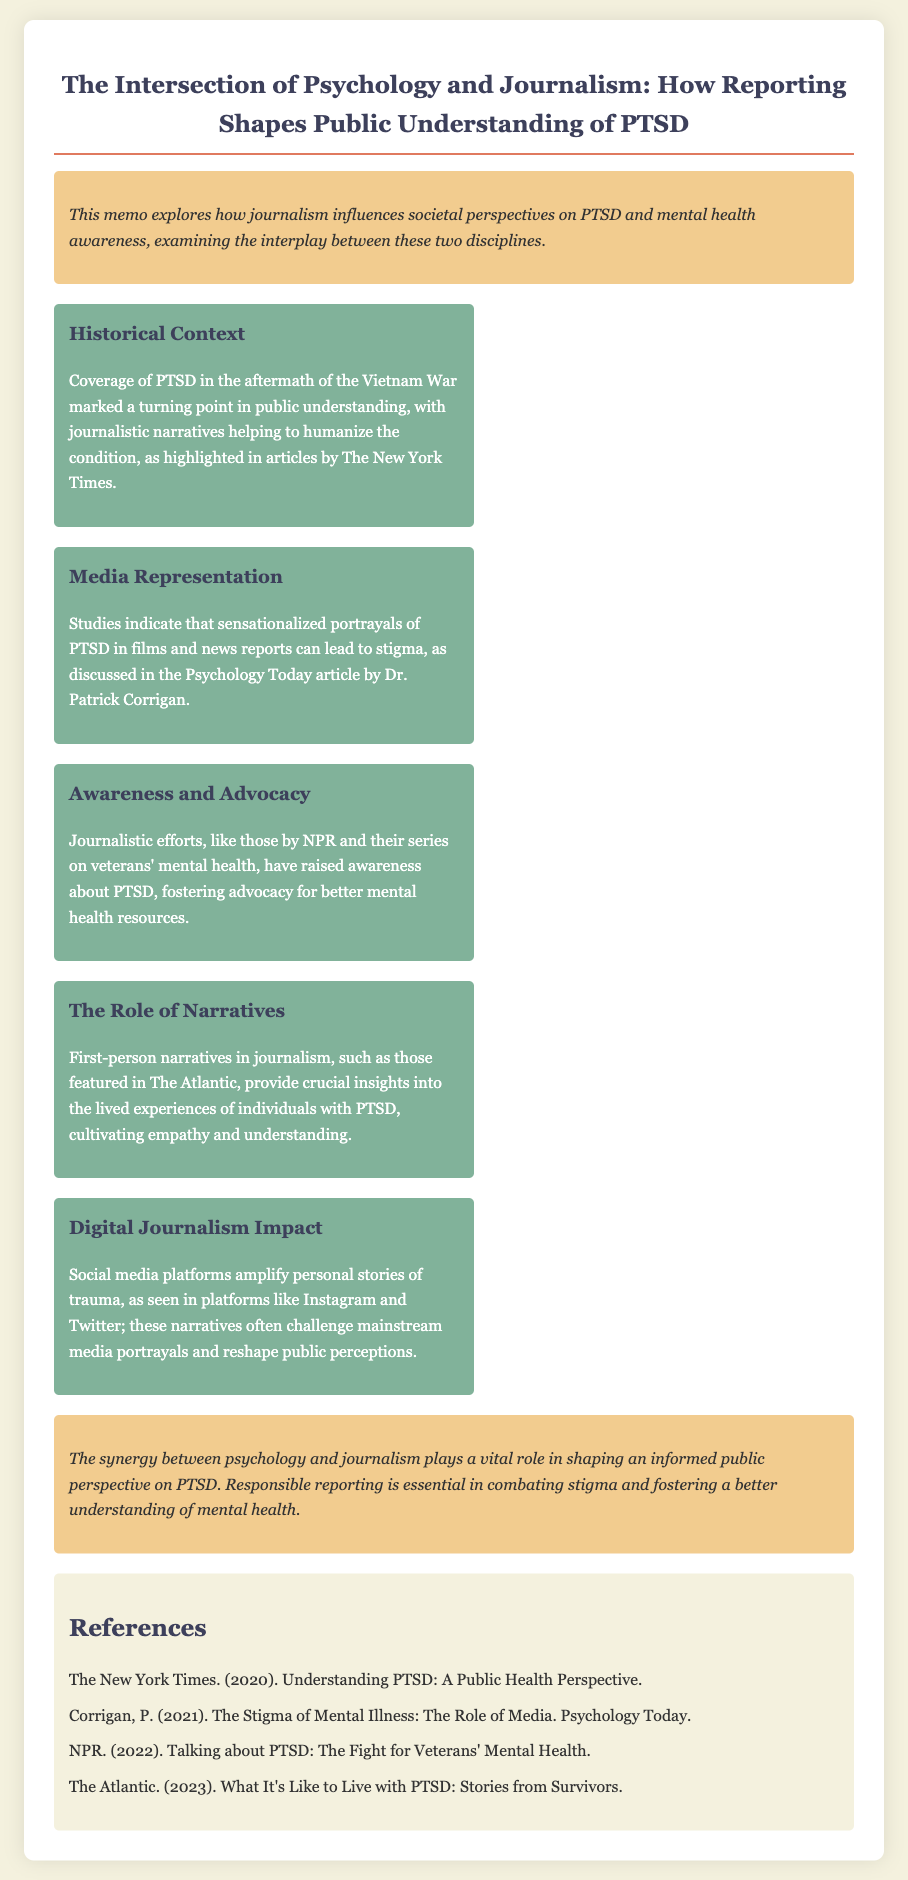What event marked a turning point in public understanding of PTSD? The document states that coverage of PTSD in the aftermath of the Vietnam War significantly impacted societal views on the condition.
Answer: Vietnam War Who discussed the stigma associated with PTSD in media? The memo references Dr. Patrick Corrigan's article in Psychology Today about the stigma of mental illness and media representation.
Answer: Dr. Patrick Corrigan Which organization raised awareness about veterans' mental health? The document mentions that NPR's series addressed veterans' mental health issues, contributing to awareness efforts.
Answer: NPR What role do first-person narratives play in journalism about PTSD? According to the document, these narratives provide insights into lived experiences and foster empathy and understanding among readers.
Answer: Empathy and understanding In what year did The Atlantic publish stories from PTSD survivors? The memo lists 2023 as the year when The Atlantic featured articles on living with PTSD.
Answer: 2023 